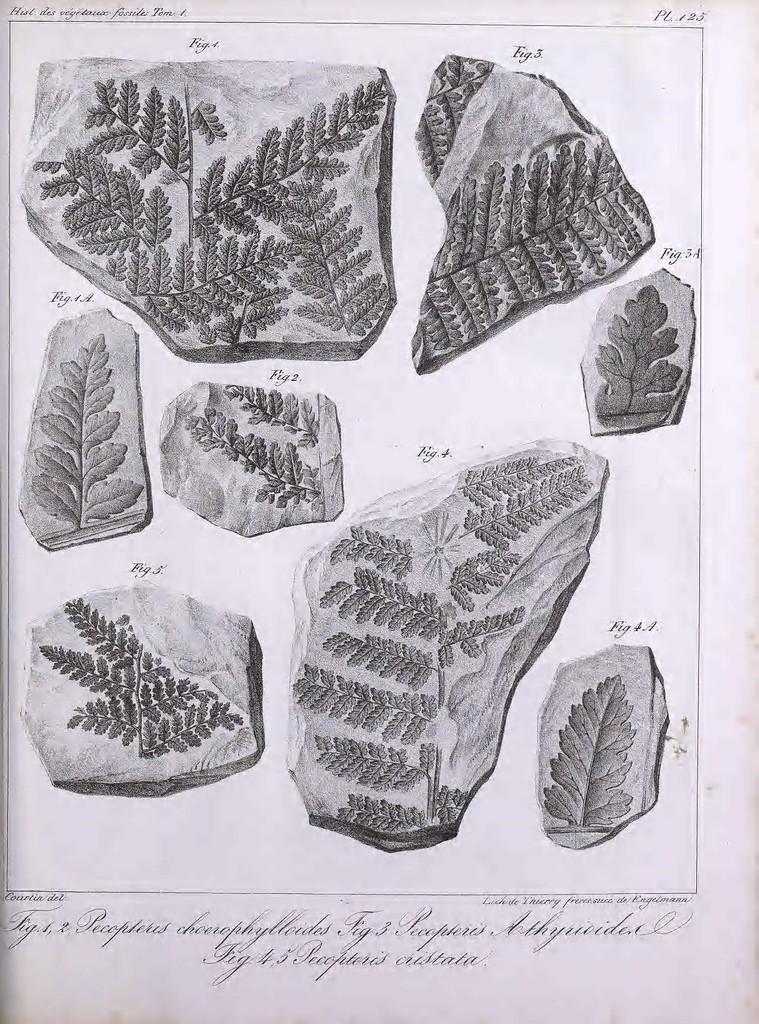In one or two sentences, can you explain what this image depicts? In this image I can see a picture of rocks and leaves in the paper. 